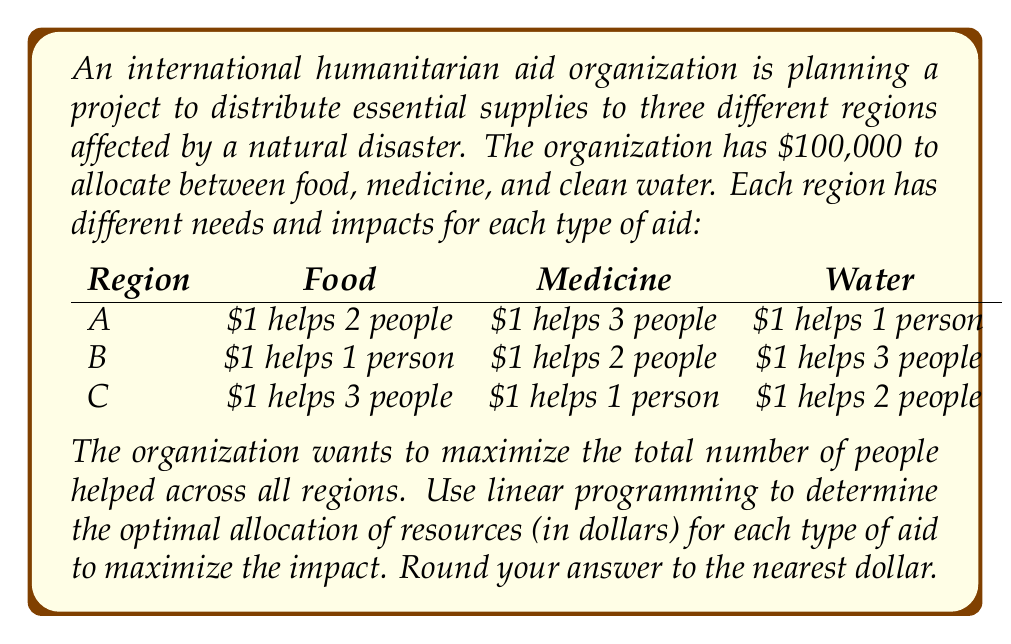Can you solve this math problem? To solve this problem, we'll use linear programming. Let's define our variables:

$x$ = amount spent on food
$y$ = amount spent on medicine
$z$ = amount spent on water

Our objective function is to maximize the total number of people helped:

$$ \text{Maximize: } 2x + 3y + z + x + 2y + 3z + 3x + y + 2z $$
$$ = 6x + 6y + 6z $$

Subject to the constraints:

1. Total budget: $x + y + z \leq 100000$
2. Non-negativity: $x \geq 0, y \geq 0, z \geq 0$

To solve this, we can use the simplex method or a linear programming solver. However, we can also observe that the coefficients in the objective function are all equal (6). This means that any allocation of the full budget will result in the same maximum value.

Therefore, we can choose any allocation that uses the entire budget. For simplicity, let's allocate the entire budget to food:

$x = 100000$
$y = 0$
$z = 0$

This allocation will help:

$$ 6 \times 100000 = 600000 \text{ people} $$

Note that any other allocation that uses the full budget (e.g., all to medicine or all to water) would result in the same total number of people helped.
Answer: Optimal allocation: $100,000 on food, $0 on medicine, $0 on water. Total people helped: 600,000. 